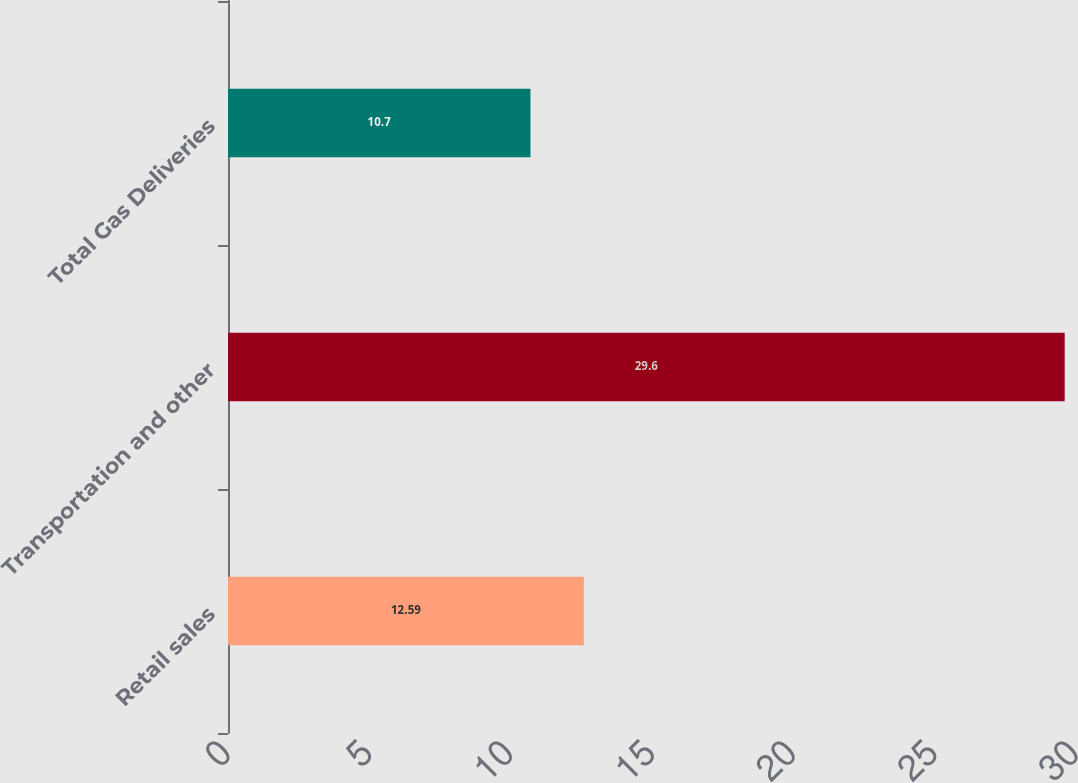<chart> <loc_0><loc_0><loc_500><loc_500><bar_chart><fcel>Retail sales<fcel>Transportation and other<fcel>Total Gas Deliveries<nl><fcel>12.59<fcel>29.6<fcel>10.7<nl></chart> 